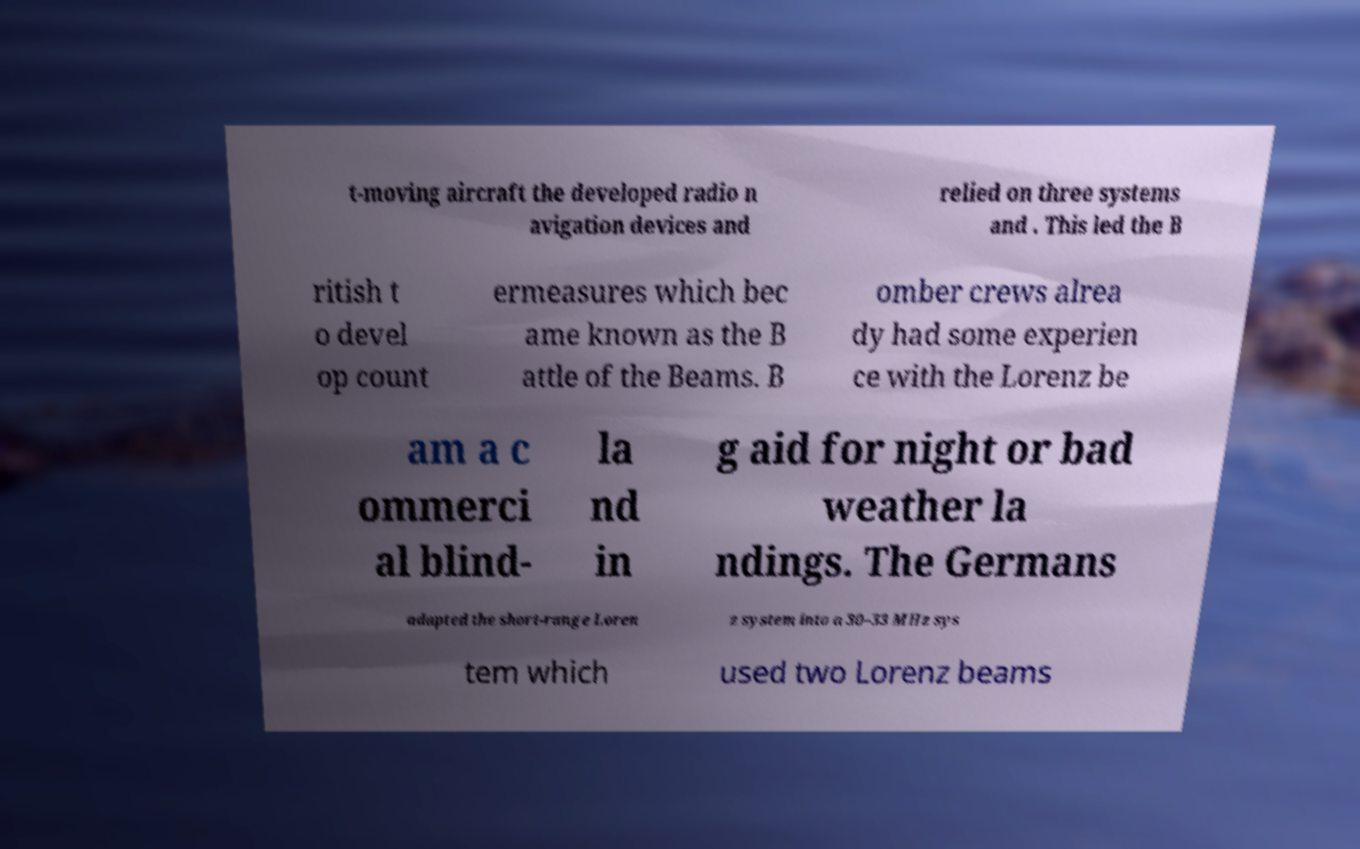There's text embedded in this image that I need extracted. Can you transcribe it verbatim? t-moving aircraft the developed radio n avigation devices and relied on three systems and . This led the B ritish t o devel op count ermeasures which bec ame known as the B attle of the Beams. B omber crews alrea dy had some experien ce with the Lorenz be am a c ommerci al blind- la nd in g aid for night or bad weather la ndings. The Germans adapted the short-range Loren z system into a 30–33 MHz sys tem which used two Lorenz beams 